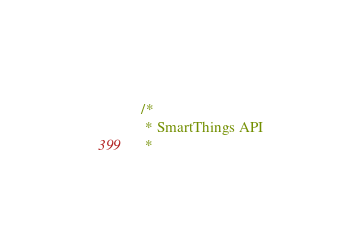<code> <loc_0><loc_0><loc_500><loc_500><_Go_>/*
 * SmartThings API
 *</code> 